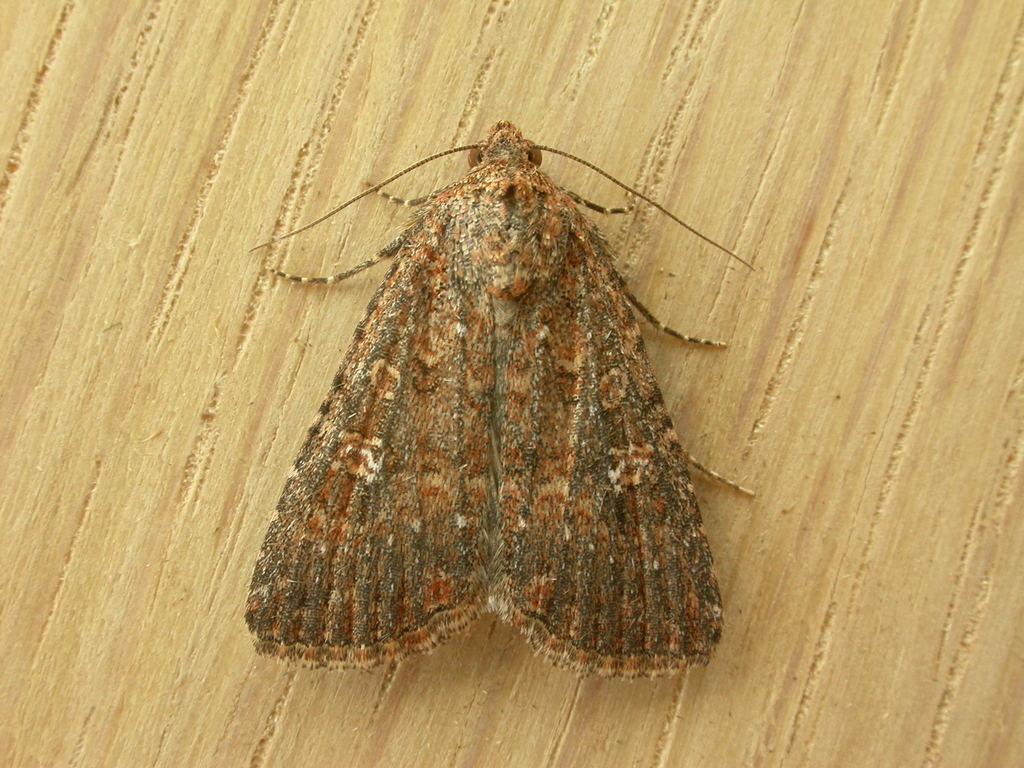Please provide a concise description of this image. Here I can see an insect on a table. 